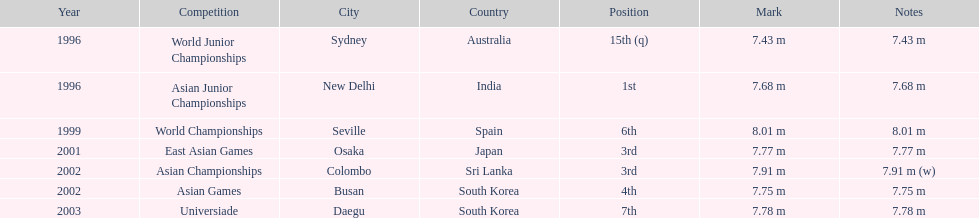What is the number of competitions that have been competed in? 7. Give me the full table as a dictionary. {'header': ['Year', 'Competition', 'City', 'Country', 'Position', 'Mark', 'Notes'], 'rows': [['1996', 'World Junior Championships', 'Sydney', 'Australia', '15th (q)', '7.43 m', '7.43 m'], ['1996', 'Asian Junior Championships', 'New Delhi', 'India', '1st', '7.68 m', '7.68 m'], ['1999', 'World Championships', 'Seville', 'Spain', '6th', '8.01 m', '8.01 m'], ['2001', 'East Asian Games', 'Osaka', 'Japan', '3rd', '7.77 m', '7.77 m'], ['2002', 'Asian Championships', 'Colombo', 'Sri Lanka', '3rd', '7.91 m', '7.91 m (w)'], ['2002', 'Asian Games', 'Busan', 'South Korea', '4th', '7.75 m', '7.75 m'], ['2003', 'Universiade', 'Daegu', 'South Korea', '7th', '7.78 m', '7.78 m']]} 